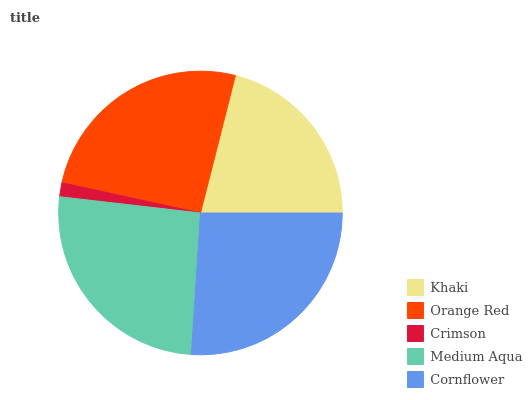Is Crimson the minimum?
Answer yes or no. Yes. Is Cornflower the maximum?
Answer yes or no. Yes. Is Orange Red the minimum?
Answer yes or no. No. Is Orange Red the maximum?
Answer yes or no. No. Is Orange Red greater than Khaki?
Answer yes or no. Yes. Is Khaki less than Orange Red?
Answer yes or no. Yes. Is Khaki greater than Orange Red?
Answer yes or no. No. Is Orange Red less than Khaki?
Answer yes or no. No. Is Orange Red the high median?
Answer yes or no. Yes. Is Orange Red the low median?
Answer yes or no. Yes. Is Medium Aqua the high median?
Answer yes or no. No. Is Crimson the low median?
Answer yes or no. No. 